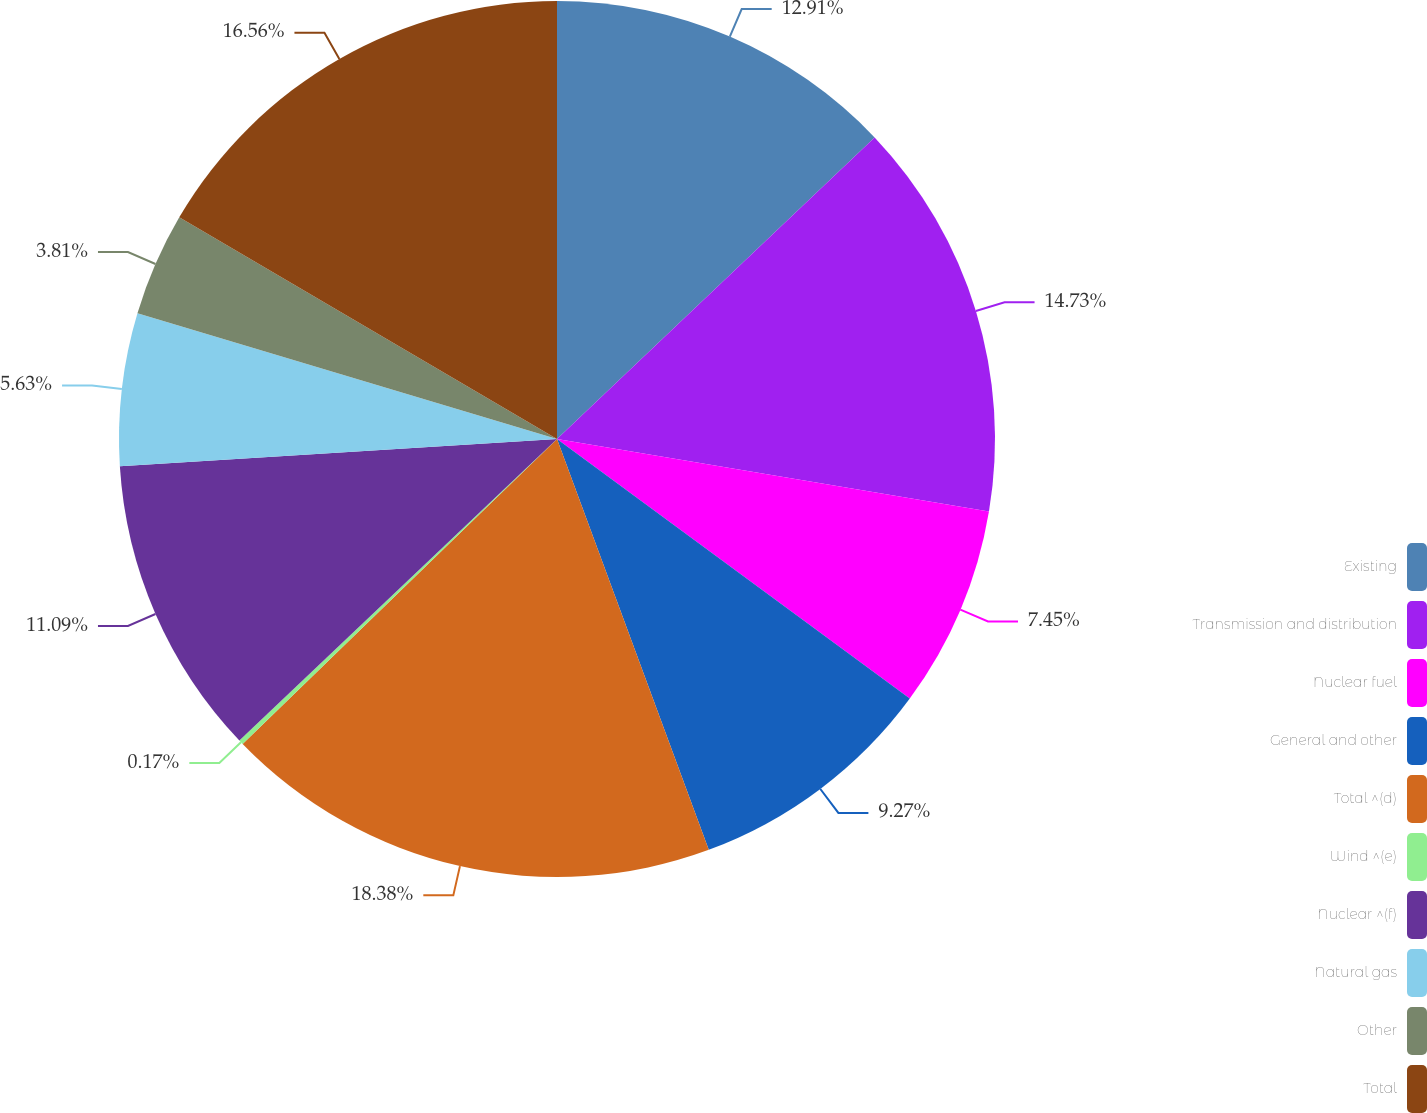Convert chart. <chart><loc_0><loc_0><loc_500><loc_500><pie_chart><fcel>Existing<fcel>Transmission and distribution<fcel>Nuclear fuel<fcel>General and other<fcel>Total ^(d)<fcel>Wind ^(e)<fcel>Nuclear ^(f)<fcel>Natural gas<fcel>Other<fcel>Total<nl><fcel>12.91%<fcel>14.73%<fcel>7.45%<fcel>9.27%<fcel>18.37%<fcel>0.17%<fcel>11.09%<fcel>5.63%<fcel>3.81%<fcel>16.55%<nl></chart> 